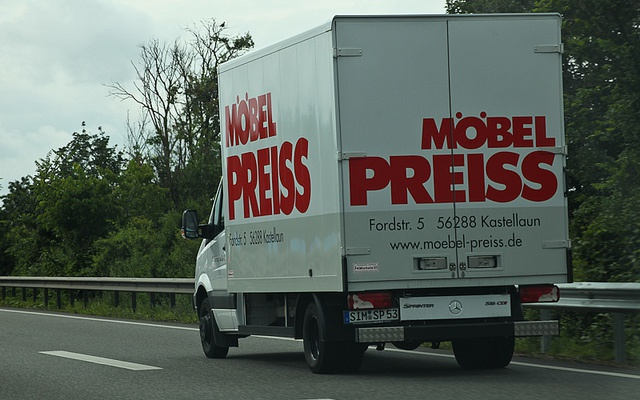Describe the objects in this image and their specific colors. I can see a truck in lightgray, gray, black, maroon, and darkgray tones in this image. 